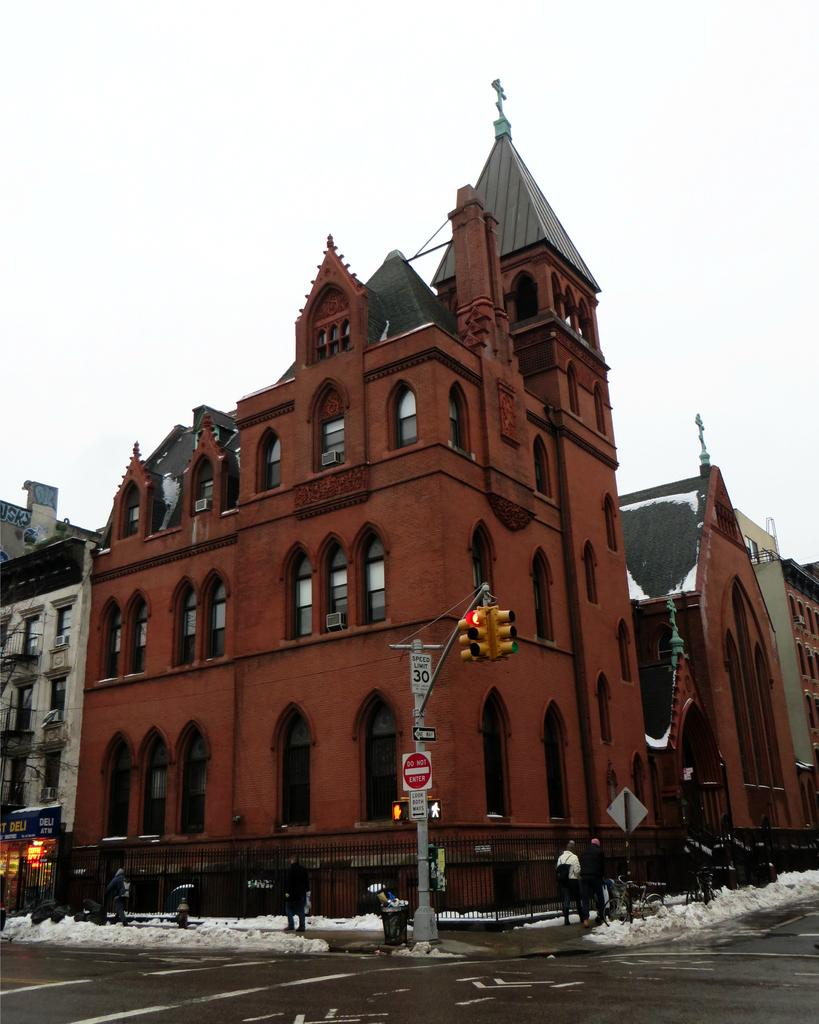What type of structures are visible in the image? There are buildings in the image. What else can be seen in the image besides the buildings? There are poles and a road at the bottom of the image. How many cherries are on the tree in the image? There is no tree or cherries present in the image. What are the children doing in the yard in the image? There are no children or yard present in the image. 